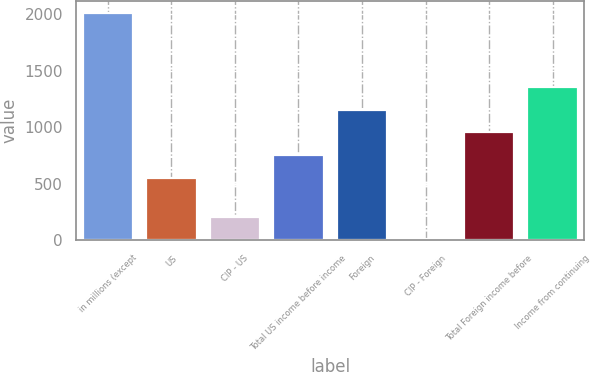<chart> <loc_0><loc_0><loc_500><loc_500><bar_chart><fcel>in millions (except<fcel>US<fcel>CIP - US<fcel>Total US income before income<fcel>Foreign<fcel>CIP - Foreign<fcel>Total Foreign income before<fcel>Income from continuing<nl><fcel>2013<fcel>553.1<fcel>209.58<fcel>753.48<fcel>1154.24<fcel>9.2<fcel>953.86<fcel>1354.62<nl></chart> 